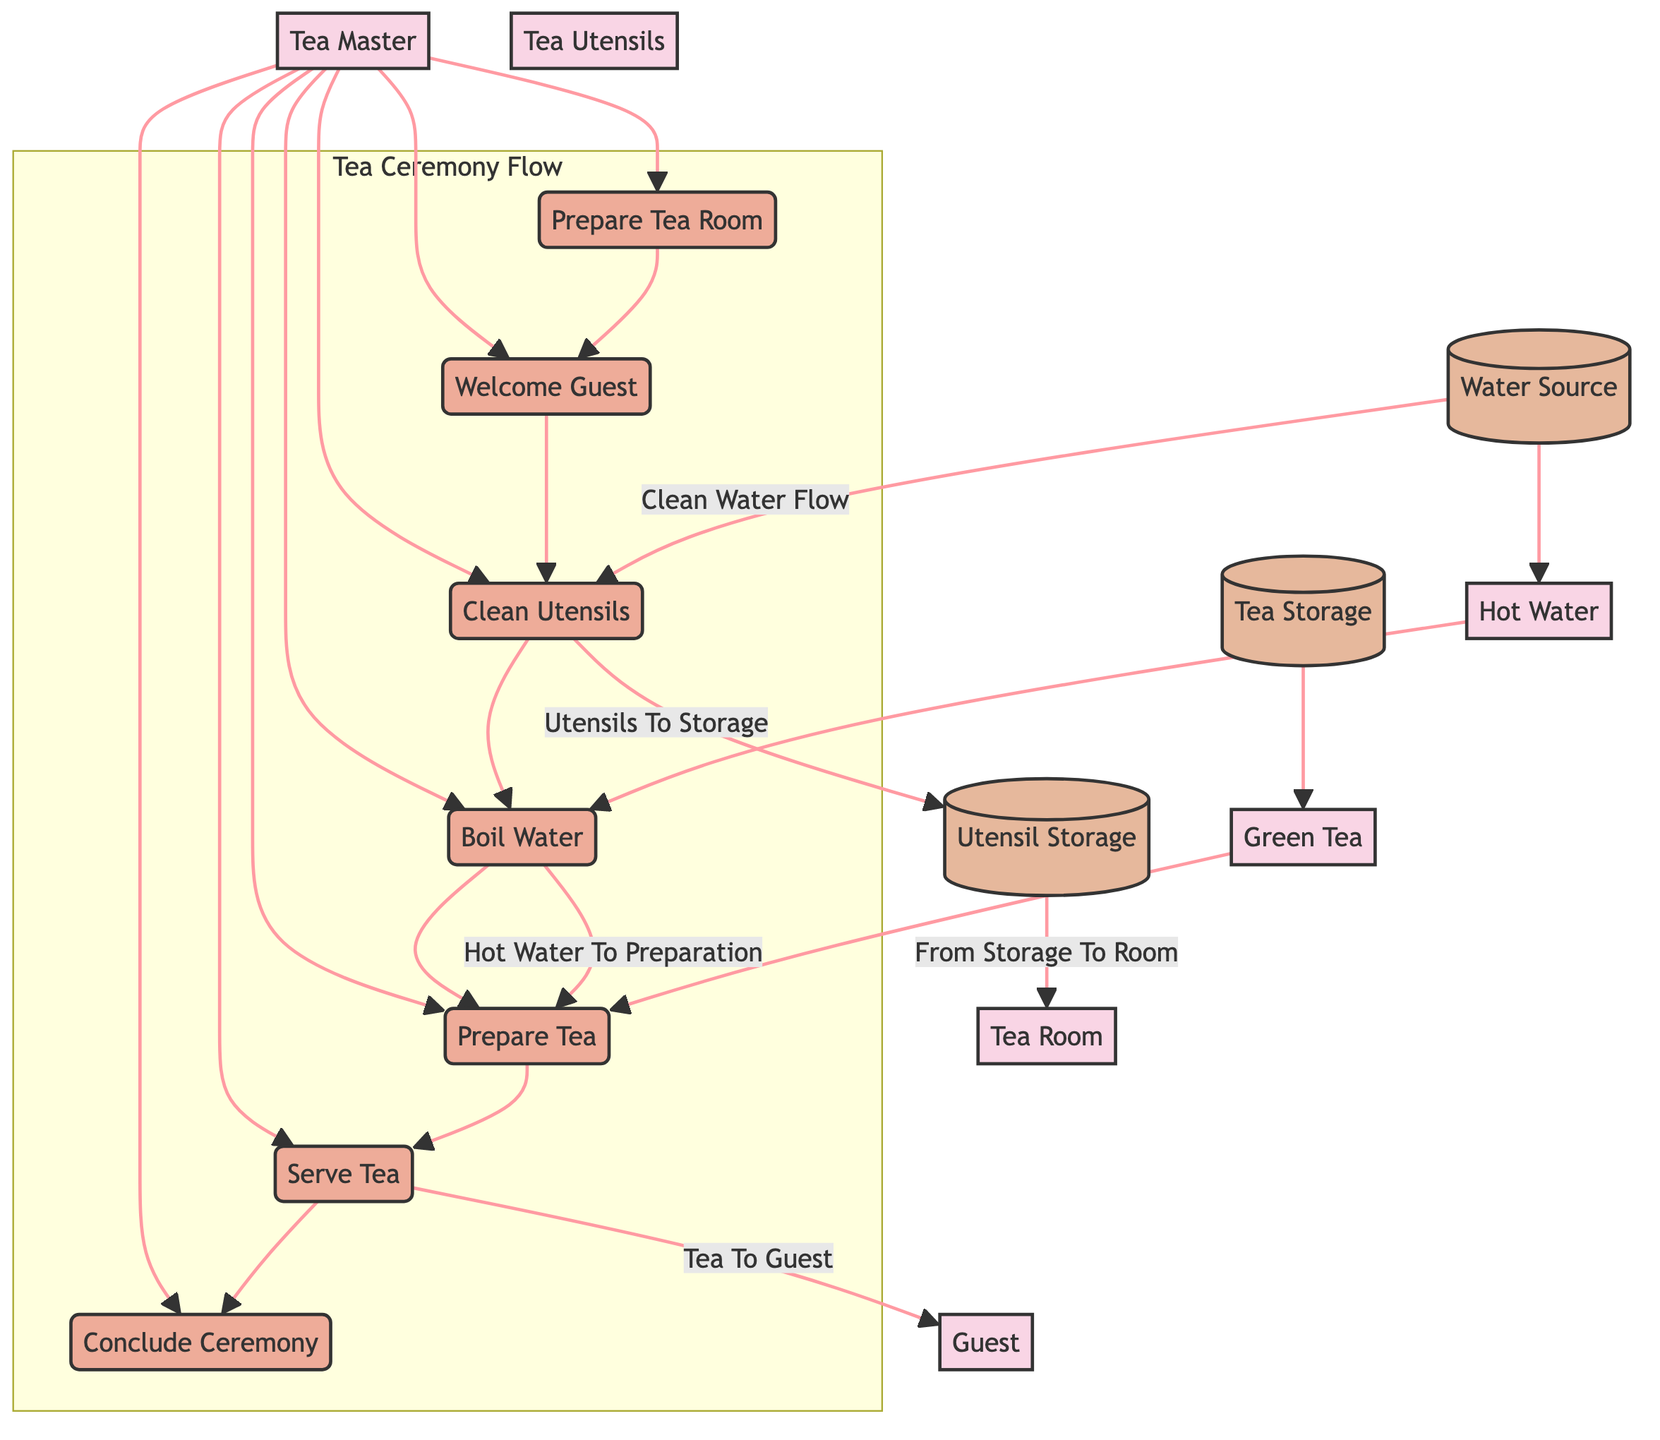What is the first process in the tea ceremony flow? The first process in the tea ceremony flow is "Prepare Tea Room," as indicated at the start of the sequence connecting the processes.
Answer: Prepare Tea Room How many data stores are present in the diagram? The diagram includes three data stores: Tea Storage, Water Source, and Utensil Storage. Counting these entities yields a total of three data stores.
Answer: 3 Which entity is responsible for welcoming the guest? The Tea Master is indicated as the entity that conducts the tea ceremony and is responsible for welcoming the guest.
Answer: Tea Master Name the flow that connects the Water Source and the Clean Utensils process. The flow between the Water Source and the Clean Utensils process is named "Clean Water Flow," illustrating the relationship between the data store and the process.
Answer: Clean Water Flow What is the last process in the tea ceremony flow? The last process in the tea ceremony sequence is "Conclude Ceremony," marking the formal end of the tea ceremony as shown in the diagram.
Answer: Conclude Ceremony How does hot water reach the Prepare Tea process? Hot water is transferred from the "Boil Water" process to the "Prepare Tea" process, indicating that the heating of water directly influences the preparation.
Answer: Hot Water To Preparation Which utensil flow denotes the return of cleaned utensils to storage? The flow indicating the return of cleaned utensils to storage is labeled "Utensils To Storage," showing the completion of cleaning and proper storage of utensils.
Answer: Utensils To Storage What type of tea is associated with the process of preparing tea? The tea associated with the process of preparing tea is "Green Tea," specifically mentioned in conjunction with the Tea Storage.
Answer: Green Tea 